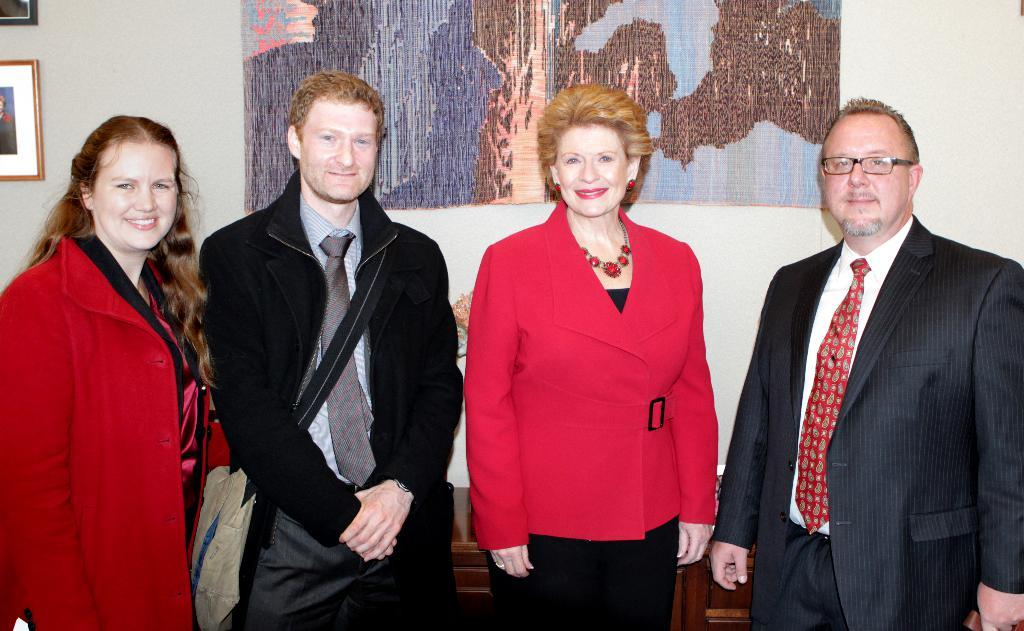How many people are in the image? There are four persons in the image. What are the persons doing in the image? The persons are standing in the image. What expression do the persons have in the image? The persons are smiling in the image. What can be seen in the background of the image? There are frames attached to the wall in the background of the image. What type of business is being conducted in the bedroom in the image? There is no bedroom or business present in the image; it features four persons standing and smiling. 